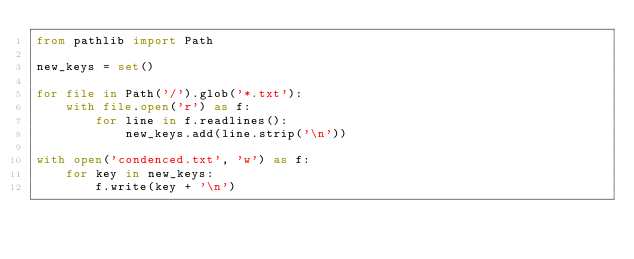Convert code to text. <code><loc_0><loc_0><loc_500><loc_500><_Python_>from pathlib import Path

new_keys = set()

for file in Path('/').glob('*.txt'):
    with file.open('r') as f:
        for line in f.readlines():
            new_keys.add(line.strip('\n'))

with open('condenced.txt', 'w') as f:
    for key in new_keys:
        f.write(key + '\n')
</code> 